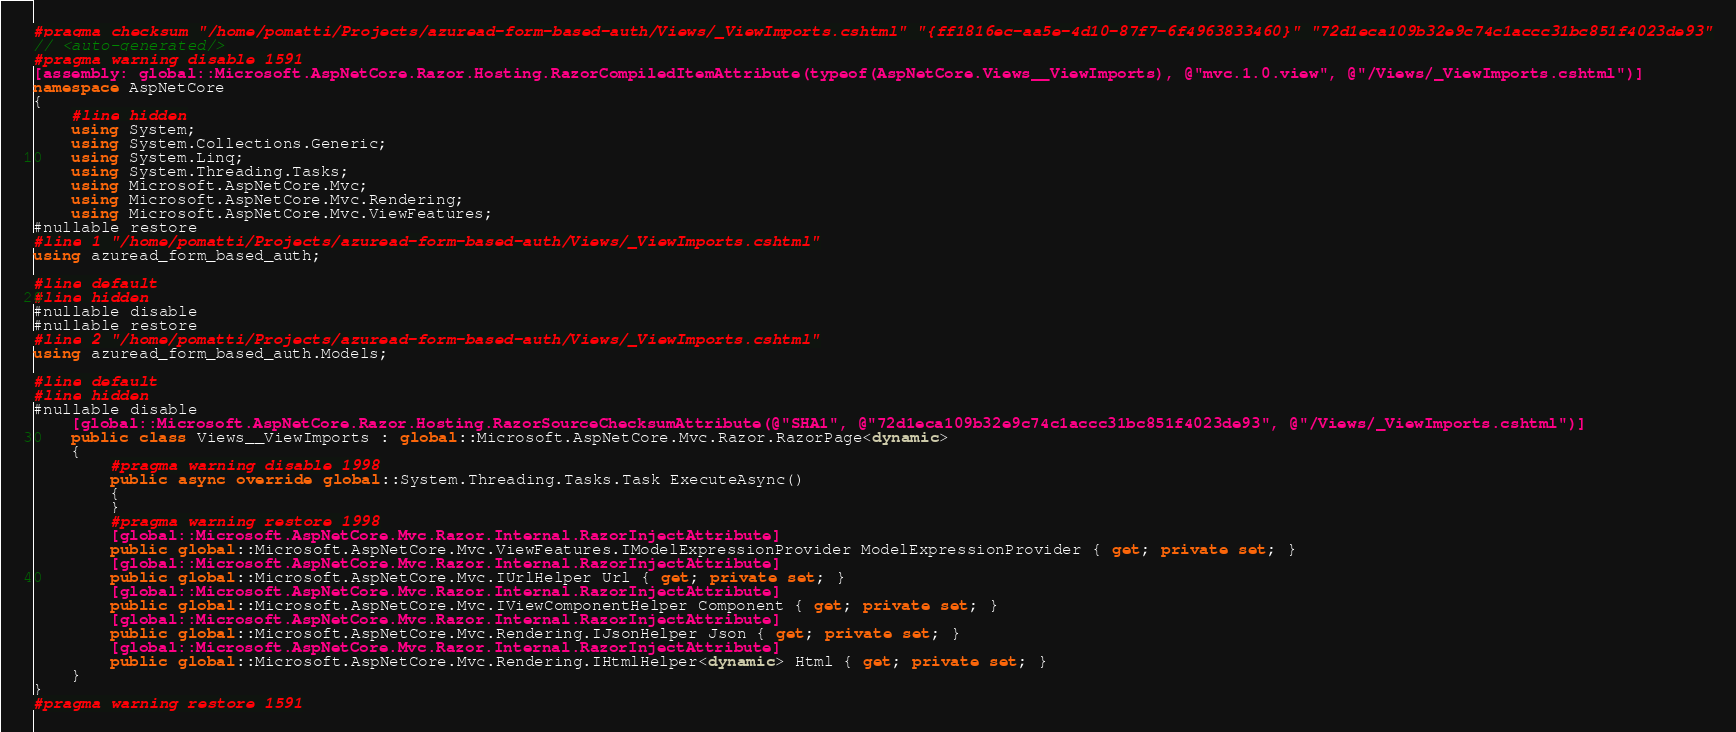Convert code to text. <code><loc_0><loc_0><loc_500><loc_500><_C#_>#pragma checksum "/home/pomatti/Projects/azuread-form-based-auth/Views/_ViewImports.cshtml" "{ff1816ec-aa5e-4d10-87f7-6f4963833460}" "72d1eca109b32e9c74c1accc31bc851f4023de93"
// <auto-generated/>
#pragma warning disable 1591
[assembly: global::Microsoft.AspNetCore.Razor.Hosting.RazorCompiledItemAttribute(typeof(AspNetCore.Views__ViewImports), @"mvc.1.0.view", @"/Views/_ViewImports.cshtml")]
namespace AspNetCore
{
    #line hidden
    using System;
    using System.Collections.Generic;
    using System.Linq;
    using System.Threading.Tasks;
    using Microsoft.AspNetCore.Mvc;
    using Microsoft.AspNetCore.Mvc.Rendering;
    using Microsoft.AspNetCore.Mvc.ViewFeatures;
#nullable restore
#line 1 "/home/pomatti/Projects/azuread-form-based-auth/Views/_ViewImports.cshtml"
using azuread_form_based_auth;

#line default
#line hidden
#nullable disable
#nullable restore
#line 2 "/home/pomatti/Projects/azuread-form-based-auth/Views/_ViewImports.cshtml"
using azuread_form_based_auth.Models;

#line default
#line hidden
#nullable disable
    [global::Microsoft.AspNetCore.Razor.Hosting.RazorSourceChecksumAttribute(@"SHA1", @"72d1eca109b32e9c74c1accc31bc851f4023de93", @"/Views/_ViewImports.cshtml")]
    public class Views__ViewImports : global::Microsoft.AspNetCore.Mvc.Razor.RazorPage<dynamic>
    {
        #pragma warning disable 1998
        public async override global::System.Threading.Tasks.Task ExecuteAsync()
        {
        }
        #pragma warning restore 1998
        [global::Microsoft.AspNetCore.Mvc.Razor.Internal.RazorInjectAttribute]
        public global::Microsoft.AspNetCore.Mvc.ViewFeatures.IModelExpressionProvider ModelExpressionProvider { get; private set; }
        [global::Microsoft.AspNetCore.Mvc.Razor.Internal.RazorInjectAttribute]
        public global::Microsoft.AspNetCore.Mvc.IUrlHelper Url { get; private set; }
        [global::Microsoft.AspNetCore.Mvc.Razor.Internal.RazorInjectAttribute]
        public global::Microsoft.AspNetCore.Mvc.IViewComponentHelper Component { get; private set; }
        [global::Microsoft.AspNetCore.Mvc.Razor.Internal.RazorInjectAttribute]
        public global::Microsoft.AspNetCore.Mvc.Rendering.IJsonHelper Json { get; private set; }
        [global::Microsoft.AspNetCore.Mvc.Razor.Internal.RazorInjectAttribute]
        public global::Microsoft.AspNetCore.Mvc.Rendering.IHtmlHelper<dynamic> Html { get; private set; }
    }
}
#pragma warning restore 1591
</code> 